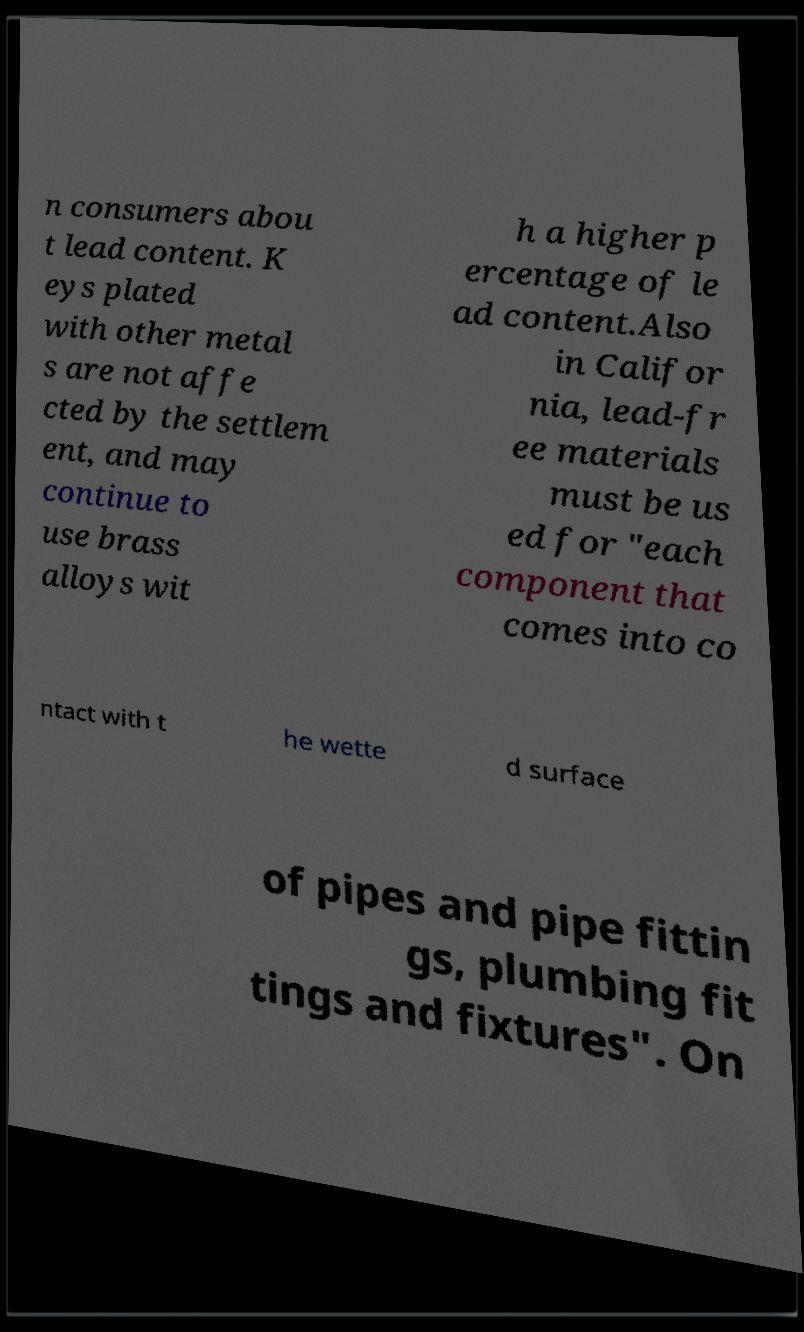Can you read and provide the text displayed in the image?This photo seems to have some interesting text. Can you extract and type it out for me? n consumers abou t lead content. K eys plated with other metal s are not affe cted by the settlem ent, and may continue to use brass alloys wit h a higher p ercentage of le ad content.Also in Califor nia, lead-fr ee materials must be us ed for "each component that comes into co ntact with t he wette d surface of pipes and pipe fittin gs, plumbing fit tings and fixtures". On 